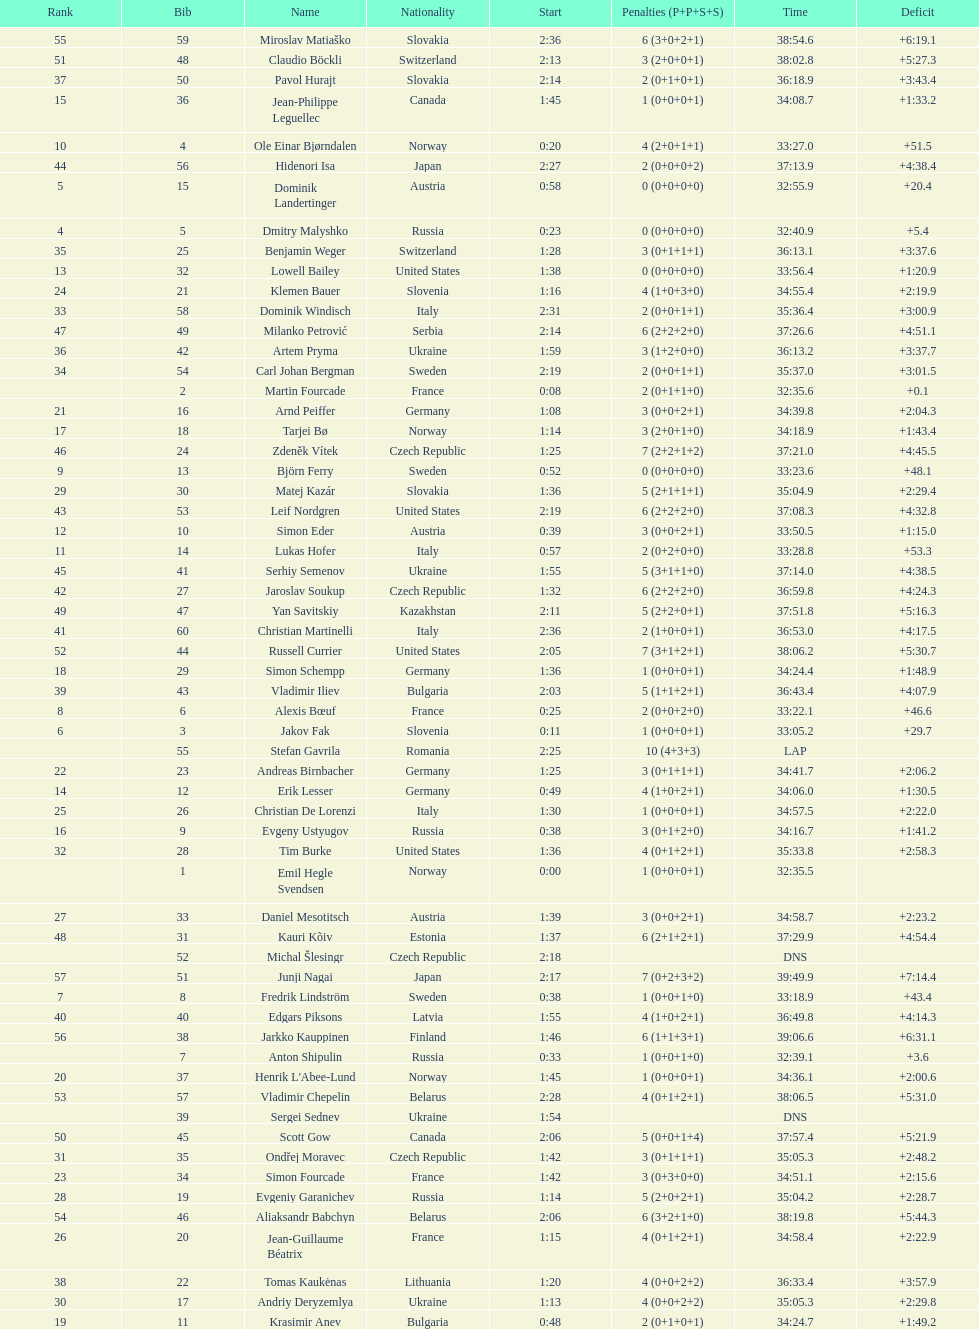Who is the top ranked runner of sweden? Fredrik Lindström. 